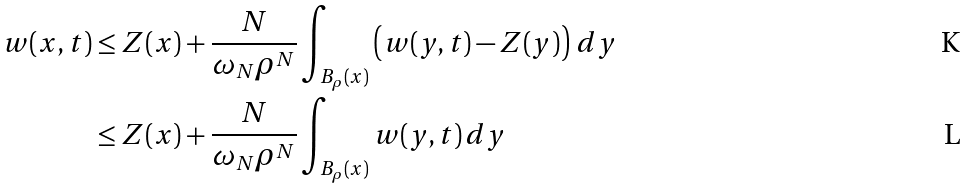<formula> <loc_0><loc_0><loc_500><loc_500>w ( x , t ) & \leq Z ( x ) + \frac { N } { \omega _ { N } \rho ^ { N } } \int _ { B _ { \rho } ( x ) } \left ( w ( y , t ) - Z ( y ) \right ) \, d y \\ & \leq Z ( x ) + \frac { N } { \omega _ { N } \rho ^ { N } } \int _ { B _ { \rho } ( x ) } w ( y , t ) \, d y</formula> 